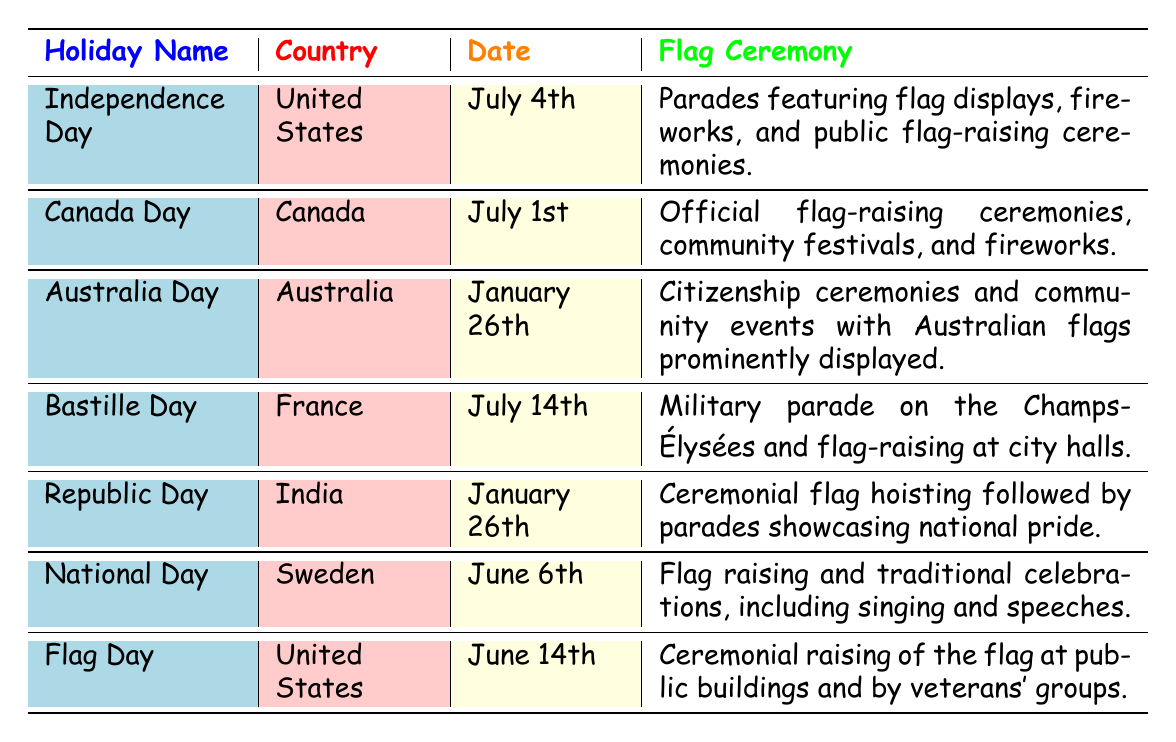What is the date of Independence Day in the United States? The table lists Independence Day in the United States, with the specific date provided in the date column. It is stated as July 4th.
Answer: July 4th Which holiday is celebrated on June 14th in the United States? The table indicates that the holiday celebrated on June 14th in the United States is Flag Day, which is explicitly mentioned in the holiday name column.
Answer: Flag Day Do Canada Day and Independence Day occur in the same month? The table shows that Canada Day is celebrated on July 1st, while Independence Day occurs on July 4th. Since both holidays are in July, the answer is yes.
Answer: Yes What type of ceremonies are associated with Republic Day in India? According to the table, Republic Day in India involves ceremonial flag hoisting followed by parades that showcase national pride. This information is provided in the flag ceremony column.
Answer: Ceremonial flag hoisting followed by parades How many holidays listed occur in the month of July? By examining the table, we see that there are two holidays in July: Canada Day on July 1st and Independence Day on July 4th. We count these two holidays to reach the answer.
Answer: 2 Is there any holiday that features a military parade? The table specifies that Bastille Day in France features a military parade on the Champs-Élysées, indicating that there is indeed a holiday with this characteristic.
Answer: Yes Which country has a holiday called National Day on June 6th? The table explicitly lists Sweden as the country that celebrates National Day on June 6th, as stated in the corresponding columns.
Answer: Sweden What are the flag ceremonies associated with Australia Day? The table outlines that Australia Day involves citizenship ceremonies and community events with Australian flags prominently displayed. This information is directly accessible in the flag ceremony column.
Answer: Citizenship ceremonies and community events with Australian flags prominently displayed How many holidays in the table are celebrated in January? From the table, we identify that there are two holidays celebrated in January: Australia Day on January 26th and Republic Day also on January 26th. Therefore, we sum these to conclude there are two holidays in January.
Answer: 2 